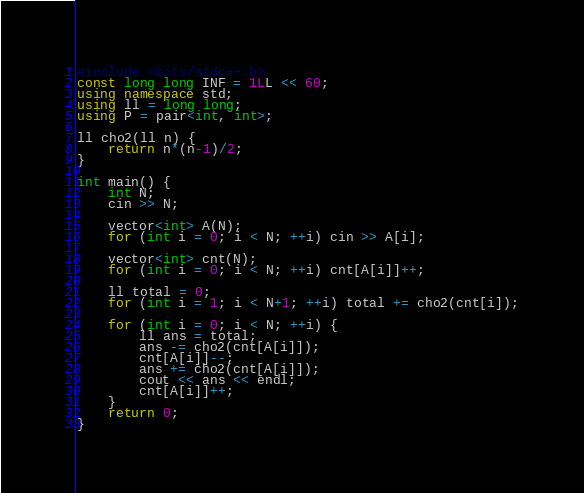Convert code to text. <code><loc_0><loc_0><loc_500><loc_500><_C++_>#include <bits/stdc++.h>
const long long INF = 1LL << 60;
using namespace std;
using ll = long long;
using P = pair<int, int>;

ll cho2(ll n) {
    return n*(n-1)/2;
}

int main() {
    int N;
    cin >> N;

    vector<int> A(N);
    for (int i = 0; i < N; ++i) cin >> A[i];

    vector<int> cnt(N);
    for (int i = 0; i < N; ++i) cnt[A[i]]++;

    ll total = 0;
    for (int i = 1; i < N+1; ++i) total += cho2(cnt[i]);

    for (int i = 0; i < N; ++i) {
        ll ans = total;
        ans -= cho2(cnt[A[i]]);
        cnt[A[i]]--;
        ans += cho2(cnt[A[i]]);
        cout << ans << endl;
        cnt[A[i]]++;
    }
    return 0;
}</code> 